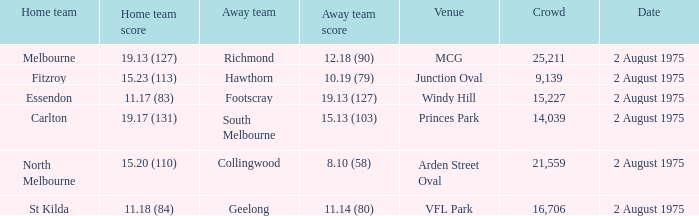18 (84)? VFL Park. Would you mind parsing the complete table? {'header': ['Home team', 'Home team score', 'Away team', 'Away team score', 'Venue', 'Crowd', 'Date'], 'rows': [['Melbourne', '19.13 (127)', 'Richmond', '12.18 (90)', 'MCG', '25,211', '2 August 1975'], ['Fitzroy', '15.23 (113)', 'Hawthorn', '10.19 (79)', 'Junction Oval', '9,139', '2 August 1975'], ['Essendon', '11.17 (83)', 'Footscray', '19.13 (127)', 'Windy Hill', '15,227', '2 August 1975'], ['Carlton', '19.17 (131)', 'South Melbourne', '15.13 (103)', 'Princes Park', '14,039', '2 August 1975'], ['North Melbourne', '15.20 (110)', 'Collingwood', '8.10 (58)', 'Arden Street Oval', '21,559', '2 August 1975'], ['St Kilda', '11.18 (84)', 'Geelong', '11.14 (80)', 'VFL Park', '16,706', '2 August 1975']]} 